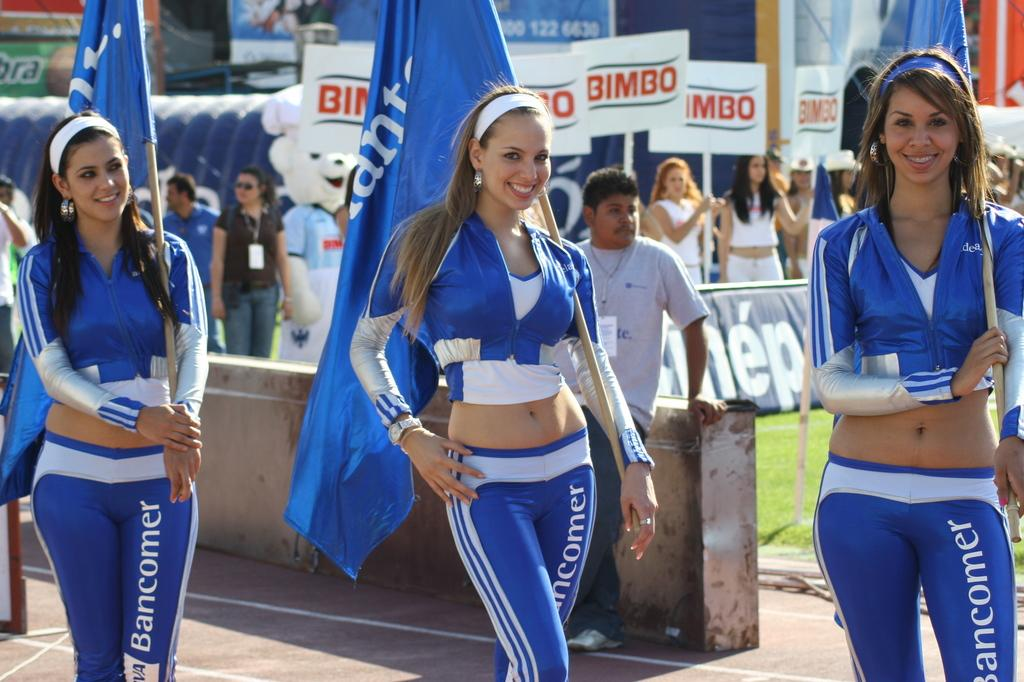<image>
Provide a brief description of the given image. A few girls wear pants with Bancomer written doen the leg. 